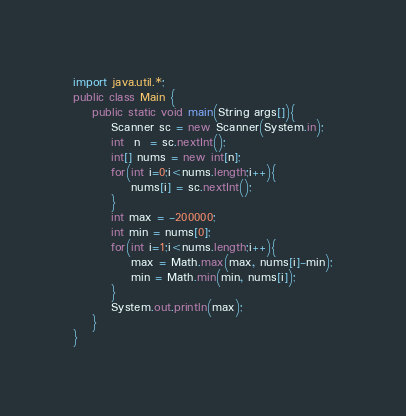Convert code to text. <code><loc_0><loc_0><loc_500><loc_500><_Java_>import java.util.*;
public class Main {
	public static void main(String args[]){
		Scanner sc = new Scanner(System.in);
		int  n  = sc.nextInt();
		int[] nums = new int[n];
		for(int i=0;i<nums.length;i++){
			nums[i] = sc.nextInt();
		}
		int max = -200000;
		int min = nums[0];
		for(int i=1;i<nums.length;i++){
			max = Math.max(max, nums[i]-min);
			min = Math.min(min, nums[i]);
		}
		System.out.println(max);
	}
}</code> 